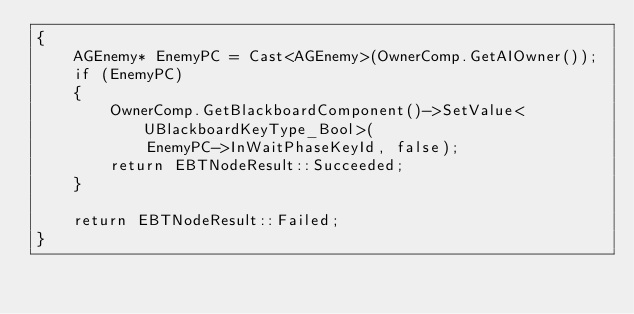Convert code to text. <code><loc_0><loc_0><loc_500><loc_500><_C++_>{
	AGEnemy* EnemyPC = Cast<AGEnemy>(OwnerComp.GetAIOwner());
	if (EnemyPC)
	{
		OwnerComp.GetBlackboardComponent()->SetValue<UBlackboardKeyType_Bool>(
			EnemyPC->InWaitPhaseKeyId, false);
		return EBTNodeResult::Succeeded;
	}

	return EBTNodeResult::Failed;
}



</code> 